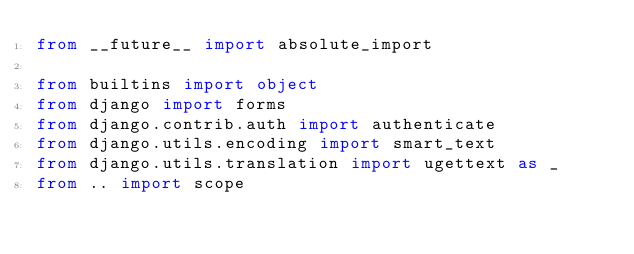<code> <loc_0><loc_0><loc_500><loc_500><_Python_>from __future__ import absolute_import

from builtins import object
from django import forms
from django.contrib.auth import authenticate
from django.utils.encoding import smart_text
from django.utils.translation import ugettext as _
from .. import scope</code> 